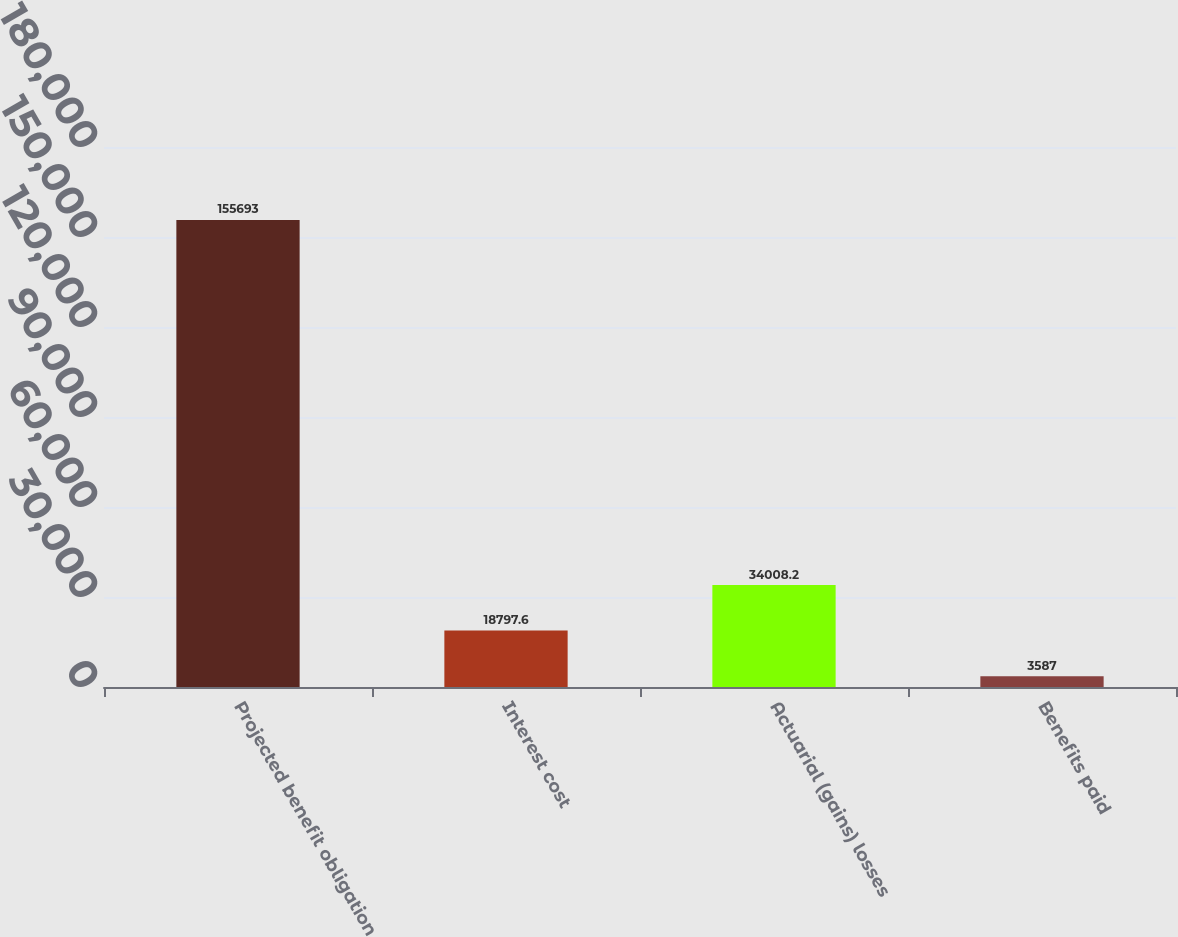Convert chart to OTSL. <chart><loc_0><loc_0><loc_500><loc_500><bar_chart><fcel>Projected benefit obligation<fcel>Interest cost<fcel>Actuarial (gains) losses<fcel>Benefits paid<nl><fcel>155693<fcel>18797.6<fcel>34008.2<fcel>3587<nl></chart> 